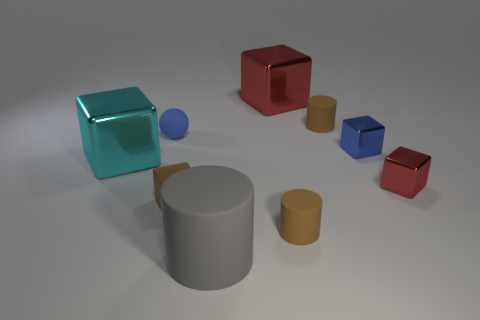Subtract all cyan blocks. How many blocks are left? 4 Subtract all yellow blocks. Subtract all purple balls. How many blocks are left? 5 Add 1 brown matte spheres. How many objects exist? 10 Subtract all blocks. How many objects are left? 4 Add 7 blue matte balls. How many blue matte balls exist? 8 Subtract 1 blue spheres. How many objects are left? 8 Subtract all purple cylinders. Subtract all big cylinders. How many objects are left? 8 Add 2 matte cylinders. How many matte cylinders are left? 5 